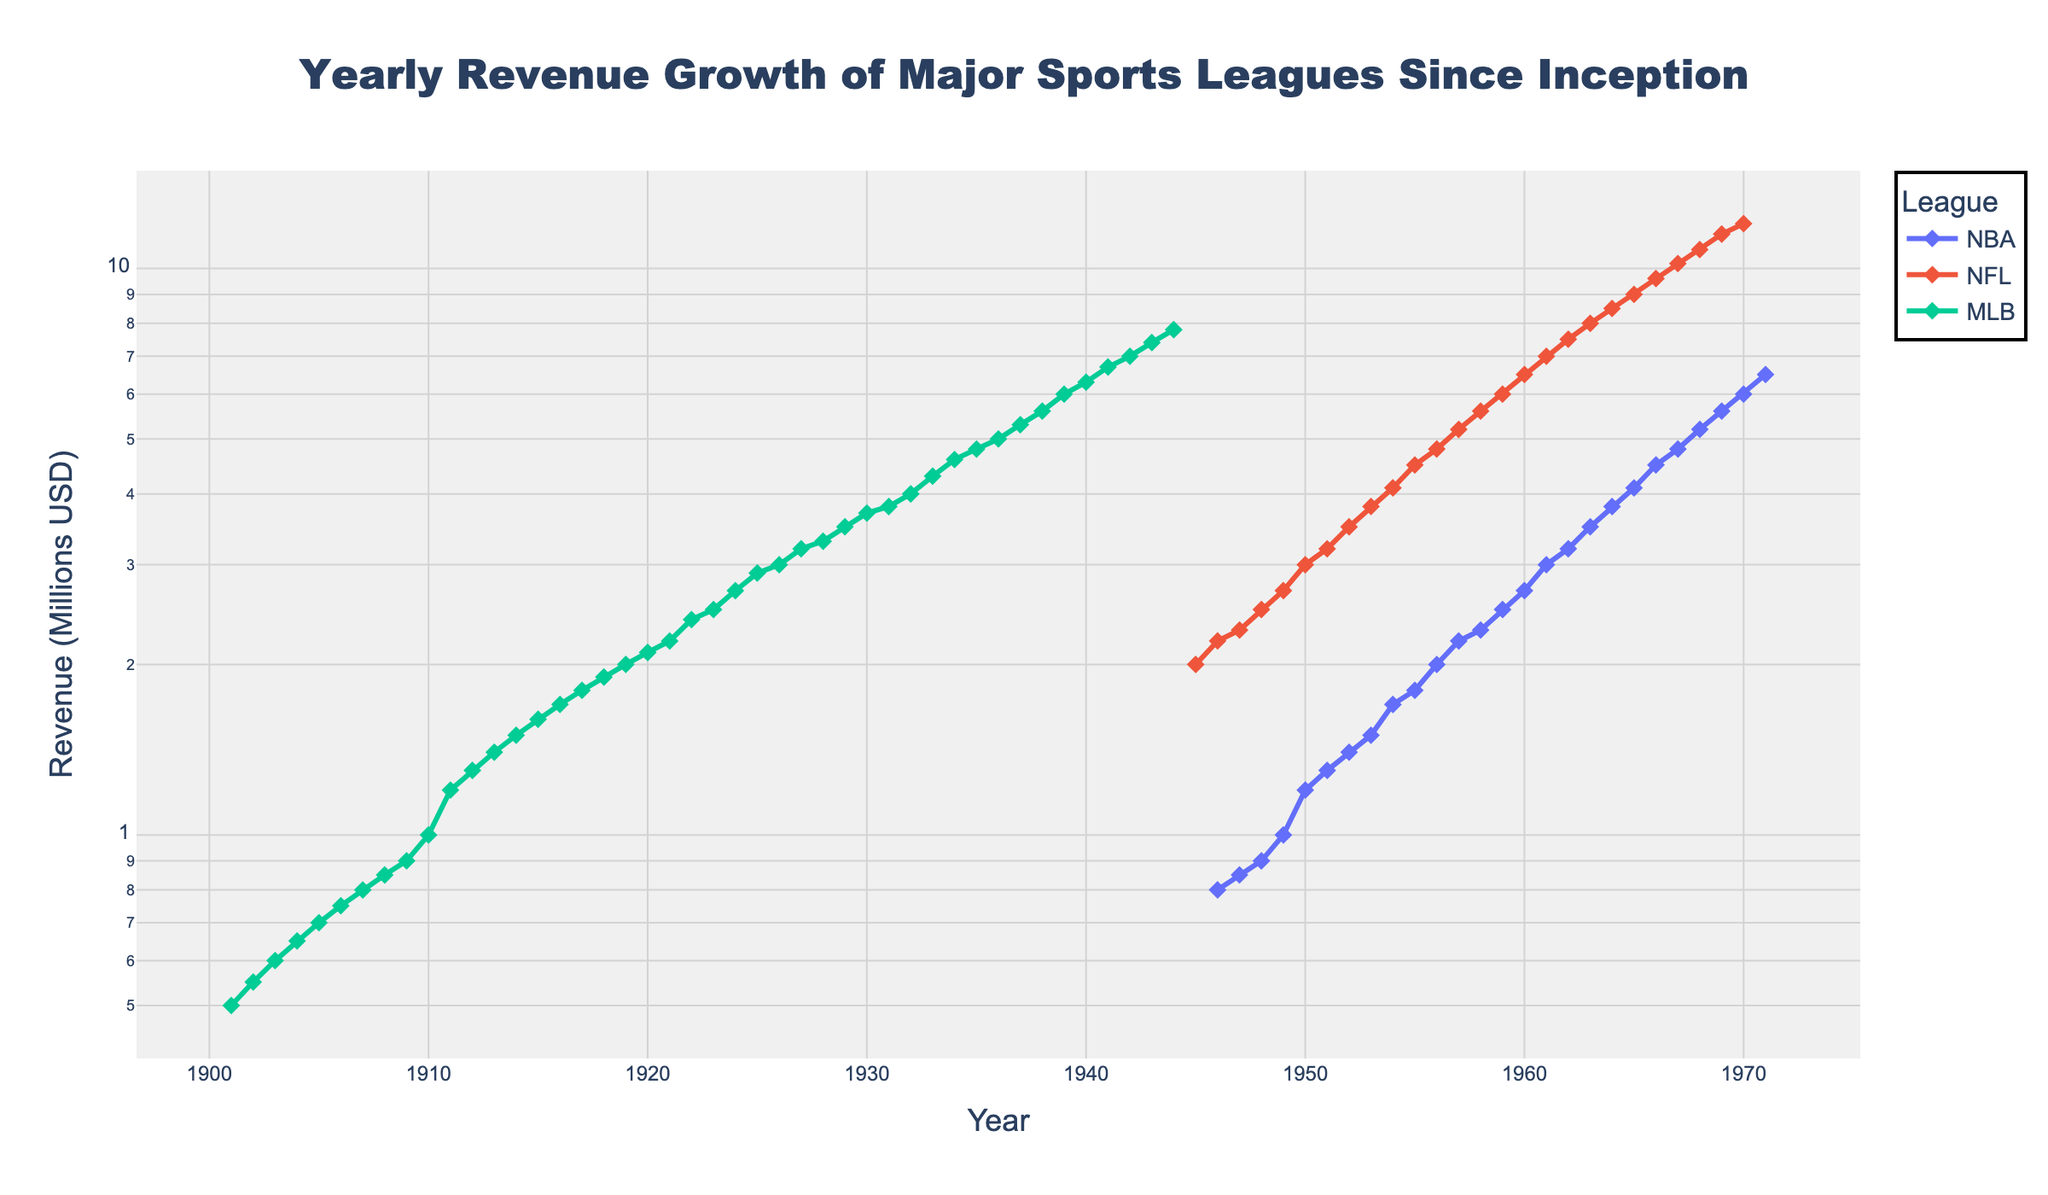What's the title of the figure? The title of the figure is usually located at the top and is often the largest text. From the provided code, the title is set as 'Yearly Revenue Growth of Major Sports Leagues Since Inception'.
Answer: Yearly Revenue Growth of Major Sports Leagues Since Inception What is the y-axis title? The y-axis title describes the measurement being plotted. According to the provided code, the y-axis title is 'Revenue (Millions USD)'.
Answer: Revenue (Millions USD) What is the x-axis title? The x-axis title describes what is being measured along the horizontal axis. The provided code indicates the x-axis title is 'Year'.
Answer: Year How is the revenue growth of the NFL compared to the NBA around the year 1960? By looking at the figure, we see two lines with markers that represent the NBA and NFL. Around 1960, the NFL revenue is at around 6.5 million USD while the NBA revenue is at around 2.7 million USD. Thus, the NFL had substantially higher revenue in 1960.
Answer: NFL had higher revenue, around 6.5 million USD compared to NBA's 2.7 million USD In which year did the MLB surpass 4 million USD in revenue? By locating the MLB line and looking for the point where it surpasses 4 million USD, we find it in the year 1932.
Answer: 1932 Which league showed the fastest initial growth in revenue? To determine initial growth, we look at the steepness of the curves at the beginning of each league's data points. The NFL shows the fastest initial growth, as its line is the steepest initially compared to NBA and MLB.
Answer: NFL From the provided data, identify which league had a revenue of exactly 7 million USD first? To find this, we need to check the lines and data points. The NFL hit 7 million USD first in the year 1961.
Answer: NFL in 1961 What is the revenue growth rate of NBA from 1950 to 1960? To find the revenue growth rate, we calculate the difference in revenue from 1960 and 1950, then divide by the revenue in 1950 and multiply by 100 to get the percentage. From 1.2 million USD in 1950 to 2.7 million USD in 1960, the rate is ((2.7-1.2)/1.2)*100 = 125%.
Answer: 125% How does the log scale of the y-axis help in understanding the revenue growth? A logarithmic scale helps in visualizing the exponential growth more clearly, as it evenly spaces the multiplicative factors, making it easier to compare rates of changes and growth trends across different orders of magnitude.
Answer: Helps visualize exponential growth clearer Between the NBA and MLB, which league shows a steadier growth in revenue over the period displayed? By observing the smoothness and consistency of the lines, the NBA shows a steadier growth with fewer sharp changes compared to the MLB line which has more fluctuations over the period displayed.
Answer: NBA 